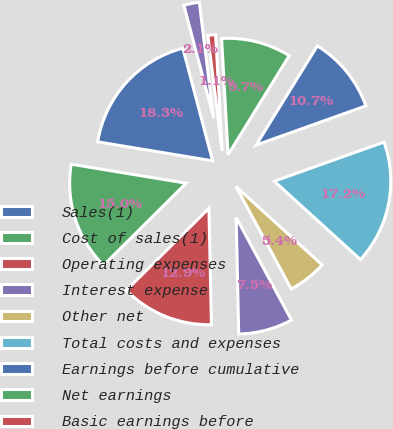Convert chart. <chart><loc_0><loc_0><loc_500><loc_500><pie_chart><fcel>Sales(1)<fcel>Cost of sales(1)<fcel>Operating expenses<fcel>Interest expense<fcel>Other net<fcel>Total costs and expenses<fcel>Earnings before cumulative<fcel>Net earnings<fcel>Basic earnings before<fcel>Diluted earnings before<nl><fcel>18.28%<fcel>15.05%<fcel>12.9%<fcel>7.53%<fcel>5.38%<fcel>17.2%<fcel>10.75%<fcel>9.68%<fcel>1.08%<fcel>2.15%<nl></chart> 